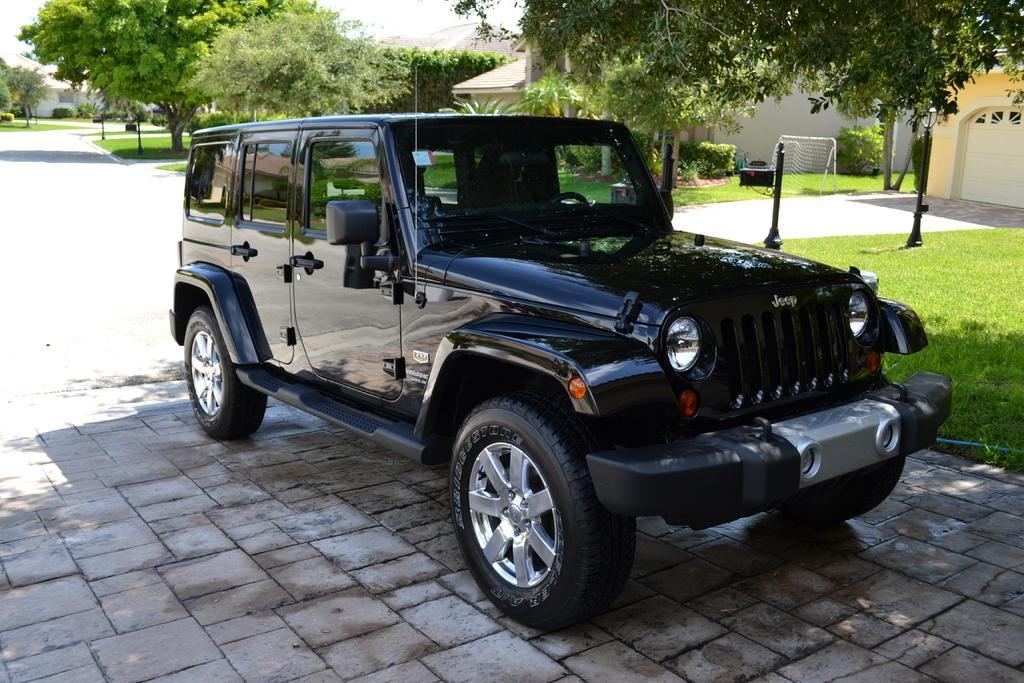Can you describe this image briefly? In the image we can see there is a vehicle. These are the headlights of the vehicle. We can even see grass, in court, there are house, trees and the sky. 